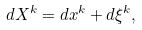<formula> <loc_0><loc_0><loc_500><loc_500>d X ^ { k } = d x ^ { k } + d \xi ^ { k } ,</formula> 